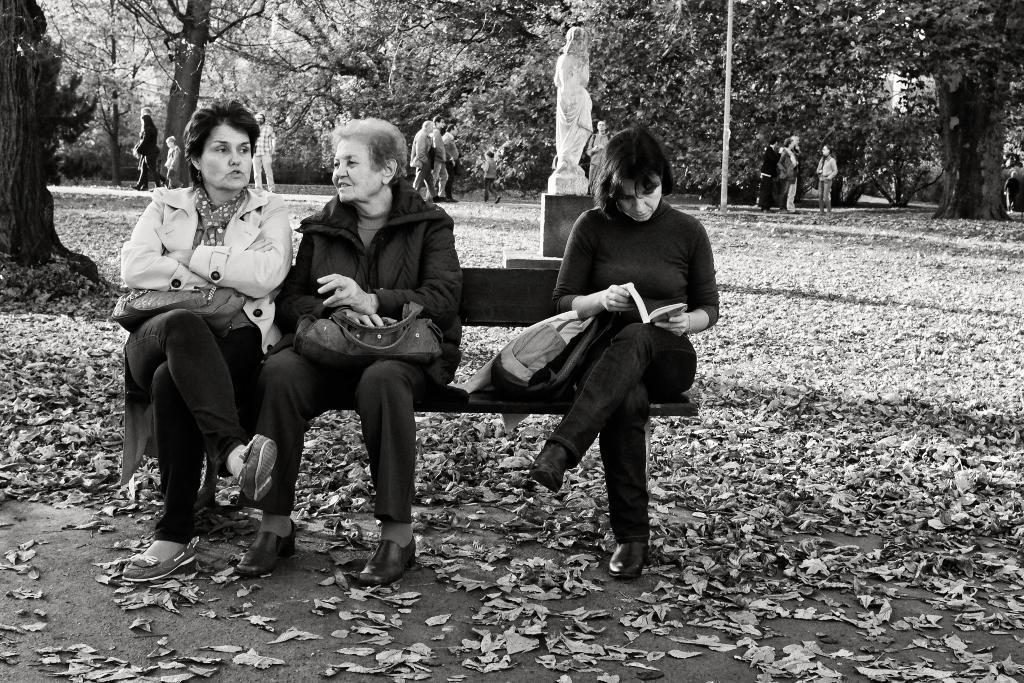Could you give a brief overview of what you see in this image? This picture is in black and white. Towards the left, there is a bench and there are three women are sitting on it. The two women towards the left are carrying bags on their laps. Beside them, there is another woman holding a book. In between them, there is a bag. At the bottom, there are dried plants. Behind them, there is a statue. In the background there are people, trees, poles etc. 